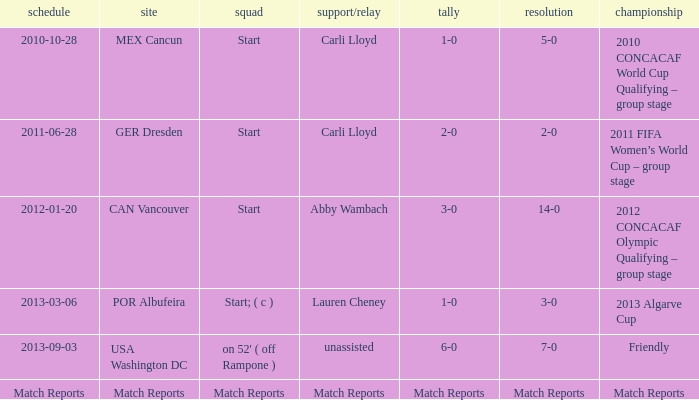Which score has a competition of match reports? Match Reports. 